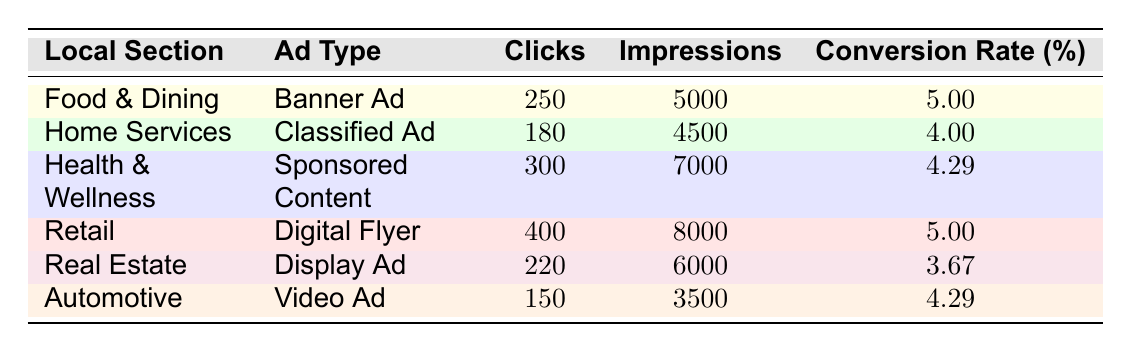What is the conversion rate for the Food & Dining section? The conversion rate for the Food & Dining section is found directly in the table and is listed as 5.00%.
Answer: 5.00% Which ad type in the Home Services section has the least number of clicks? In the Home Services section, the ad type "Classified Ad" has 180 clicks, which is the only entry for that section. Therefore, it is also the least.
Answer: 180 What is the total number of impressions across all ad types? To find the total impressions, we sum the impressions from all ad types: 5000 (Food & Dining) + 4500 (Home Services) + 7000 (Health & Wellness) + 8000 (Retail) + 6000 (Real Estate) + 3500 (Automotive) = 34000.
Answer: 34000 Is the conversion rate for the Retail section higher than that for the Real Estate section? The conversion rate for Retail is 5.00%, while for Real Estate, it is 3.67%. Since 5.00% is greater than 3.67%, the statement is true.
Answer: Yes Which section has the highest conversion rate? By comparing the conversion rates in the table, Food & Dining (5.00%) and Retail (5.00%) both have the highest conversion rates listed.
Answer: Food & Dining and Retail What is the average conversion rate across all sections? To find the average conversion rate, we add all conversion rates and divide by the number of entries: (5.00 + 4.00 + 4.29 + 5.00 + 3.67 + 4.29) / 6 = 4.52.
Answer: 4.52 Is it true that the Automotive section has a higher conversion rate than the Health & Wellness section? The conversion rate for the Automotive section is 4.29%, and for Health & Wellness, it's 4.29% as well. Thus, they are equal, and the statement is false.
Answer: No What is the difference in clicks between the highest and lowest click sections in the table? The highest number of clicks is 400 (Retail), and the lowest is 150 (Automotive). The difference is calculated as 400 - 150 = 250.
Answer: 250 